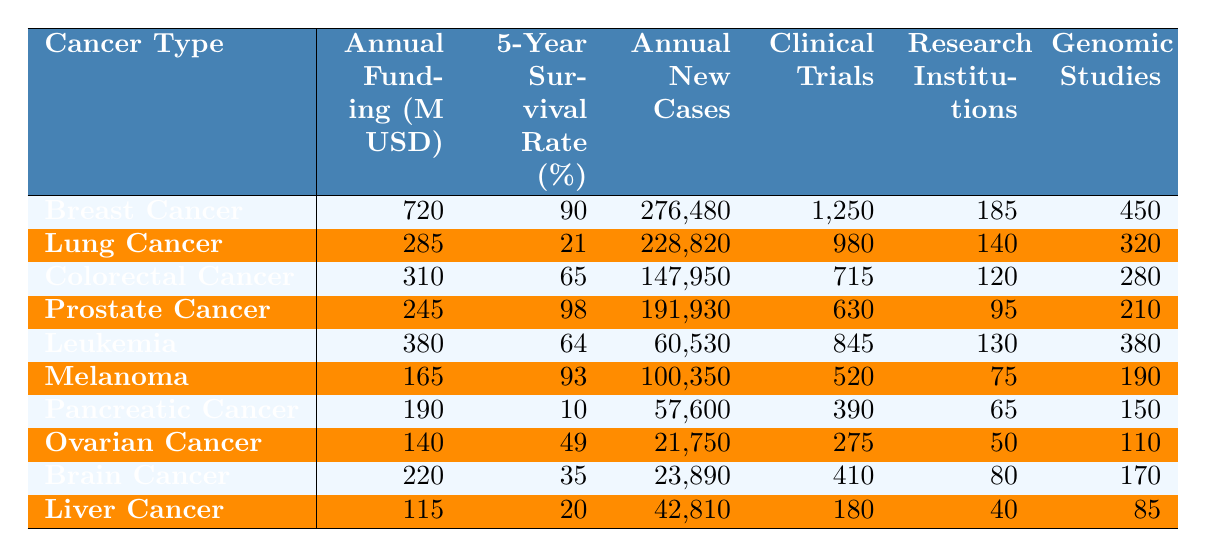What is the annual funding for Breast Cancer? The table shows the funding allocation for various cancer types, and for Breast Cancer, the annual funding value is explicitly listed as 720 million USD.
Answer: 720 million USD Which cancer type has the highest 5-year survival rate? By reviewing the survival rates in the table, Breast Cancer is indicated to have the highest survival rate at 90%.
Answer: Breast Cancer What is the number of clinical trials in progress for Lung Cancer? The table specifies that there are 980 clinical trials currently in progress for Lung Cancer, noted directly next to this cancer type.
Answer: 980 Who has more research institutions involved, Colorectal Cancer or Pancreatic Cancer? Looking at the table, Colorectal Cancer has 120 research institutions involved while Pancreatic Cancer has 65, indicating that more institutions are involved with Colorectal Cancer.
Answer: Colorectal Cancer What is the total annual funding for the cancers listed in the table? To find the total funding, sum all the annual funding values: 720 + 285 + 310 + 245 + 380 + 165 + 190 + 140 + 220 + 115 = 2,780 million USD.
Answer: 2,780 million USD What is the average 5-year survival rate across all types of cancer listed? First, sum all the survival rates: 90 + 21 + 65 + 98 + 64 + 93 + 10 + 49 + 35 + 20 =  505. Then, divide by the number of cancer types (10), resulting in an average of 50.5%.
Answer: 50.5% Which cancer type has the lowest annual new cases, and how many are there? By comparing the annual new cases, Ovarian Cancer shows the lowest number at 21,750 based on the data in the table.
Answer: Ovarian Cancer; 21,750 Is it true that Melanoma has more clinical trials in progress than Prostate Cancer? The table shows that Melanoma has 520 clinical trials while Prostate Cancer has 630. Thus, the statement is false.
Answer: No What is the difference in annual funding between Breast Cancer and Liver Cancer? Annual funding for Breast Cancer is 720 million USD and for Liver Cancer is 115 million USD. The difference is 720 - 115 = 605 million USD.
Answer: 605 million USD If we consider the 5-year survival rates, which type of cancer could be prioritized for more funding based on prognosis, and why? Given that Pancreatic Cancer has the lowest survival rate at 10%, it indicates a critical need for funding to enhance research and treatment options compared to cancers like Breast Cancer, which has much better survival rates.
Answer: Pancreatic Cancer; prioritize funding 